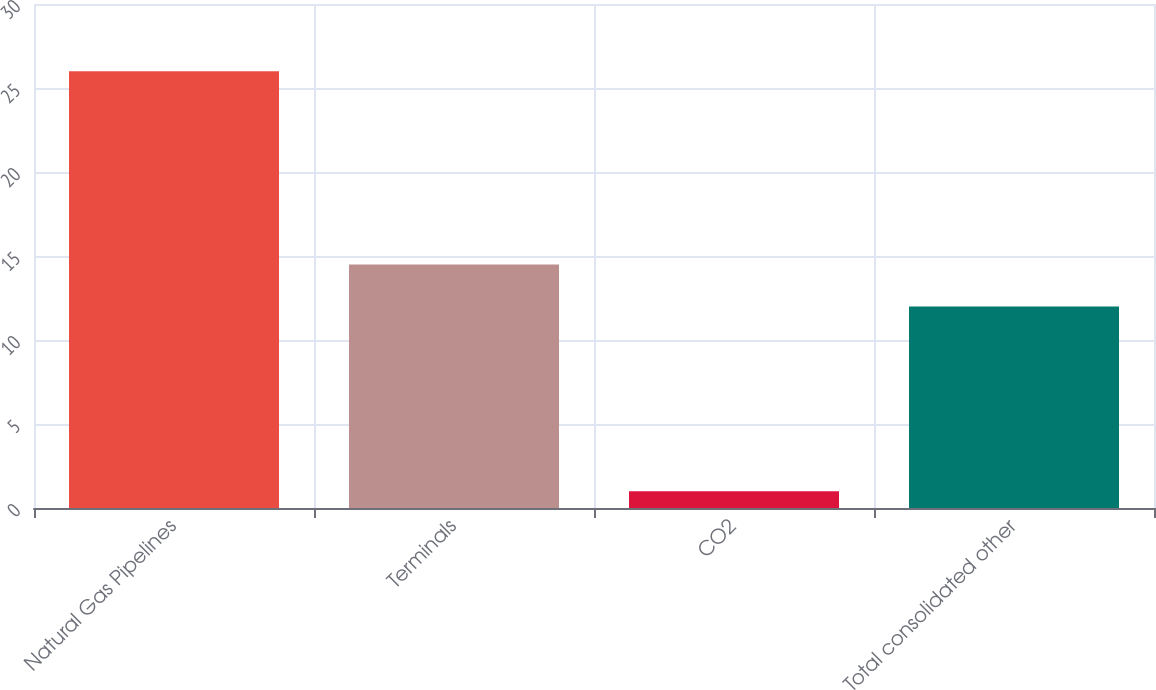<chart> <loc_0><loc_0><loc_500><loc_500><bar_chart><fcel>Natural Gas Pipelines<fcel>Terminals<fcel>CO2<fcel>Total consolidated other<nl><fcel>26<fcel>14.5<fcel>1<fcel>12<nl></chart> 